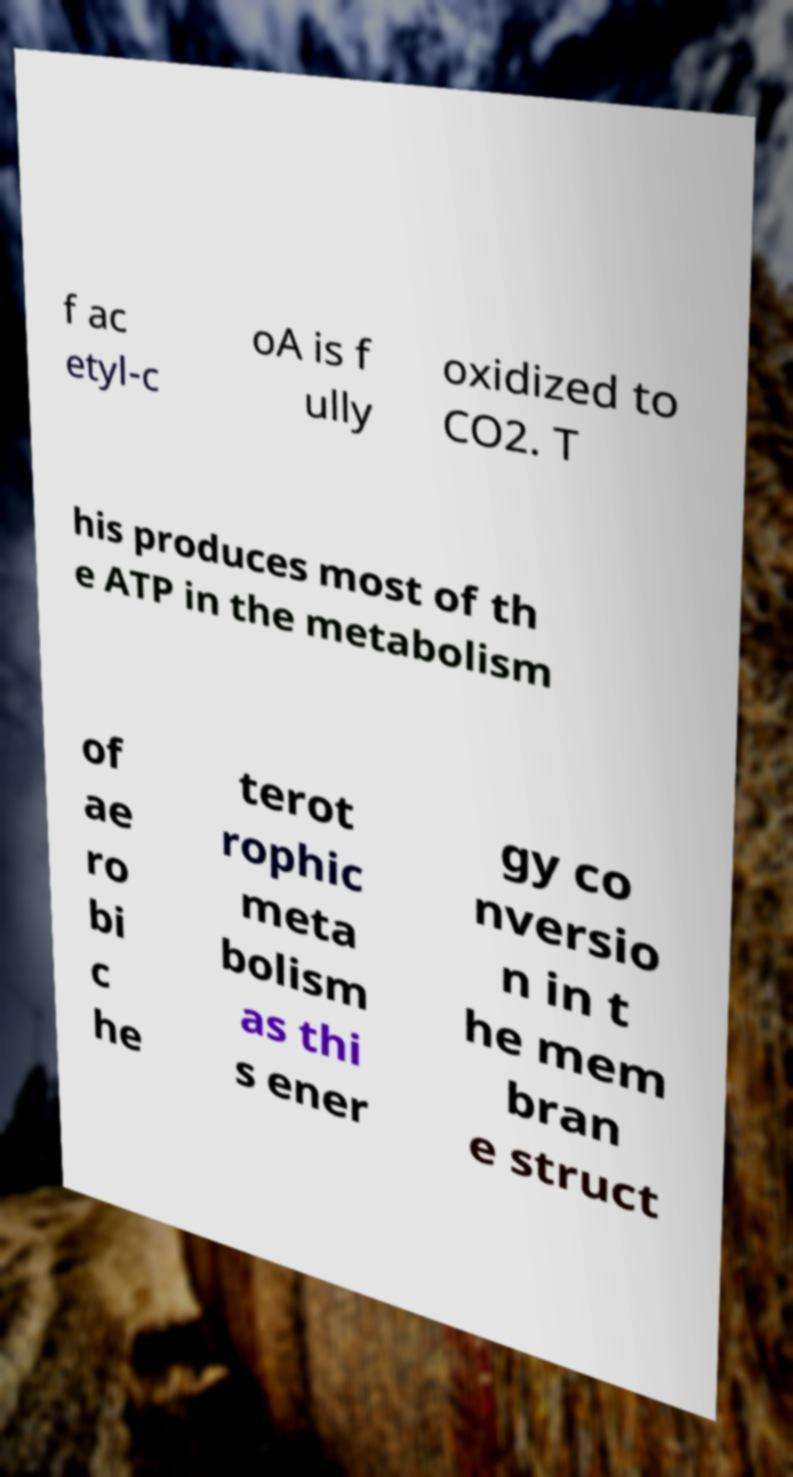Can you accurately transcribe the text from the provided image for me? f ac etyl-c oA is f ully oxidized to CO2. T his produces most of th e ATP in the metabolism of ae ro bi c he terot rophic meta bolism as thi s ener gy co nversio n in t he mem bran e struct 